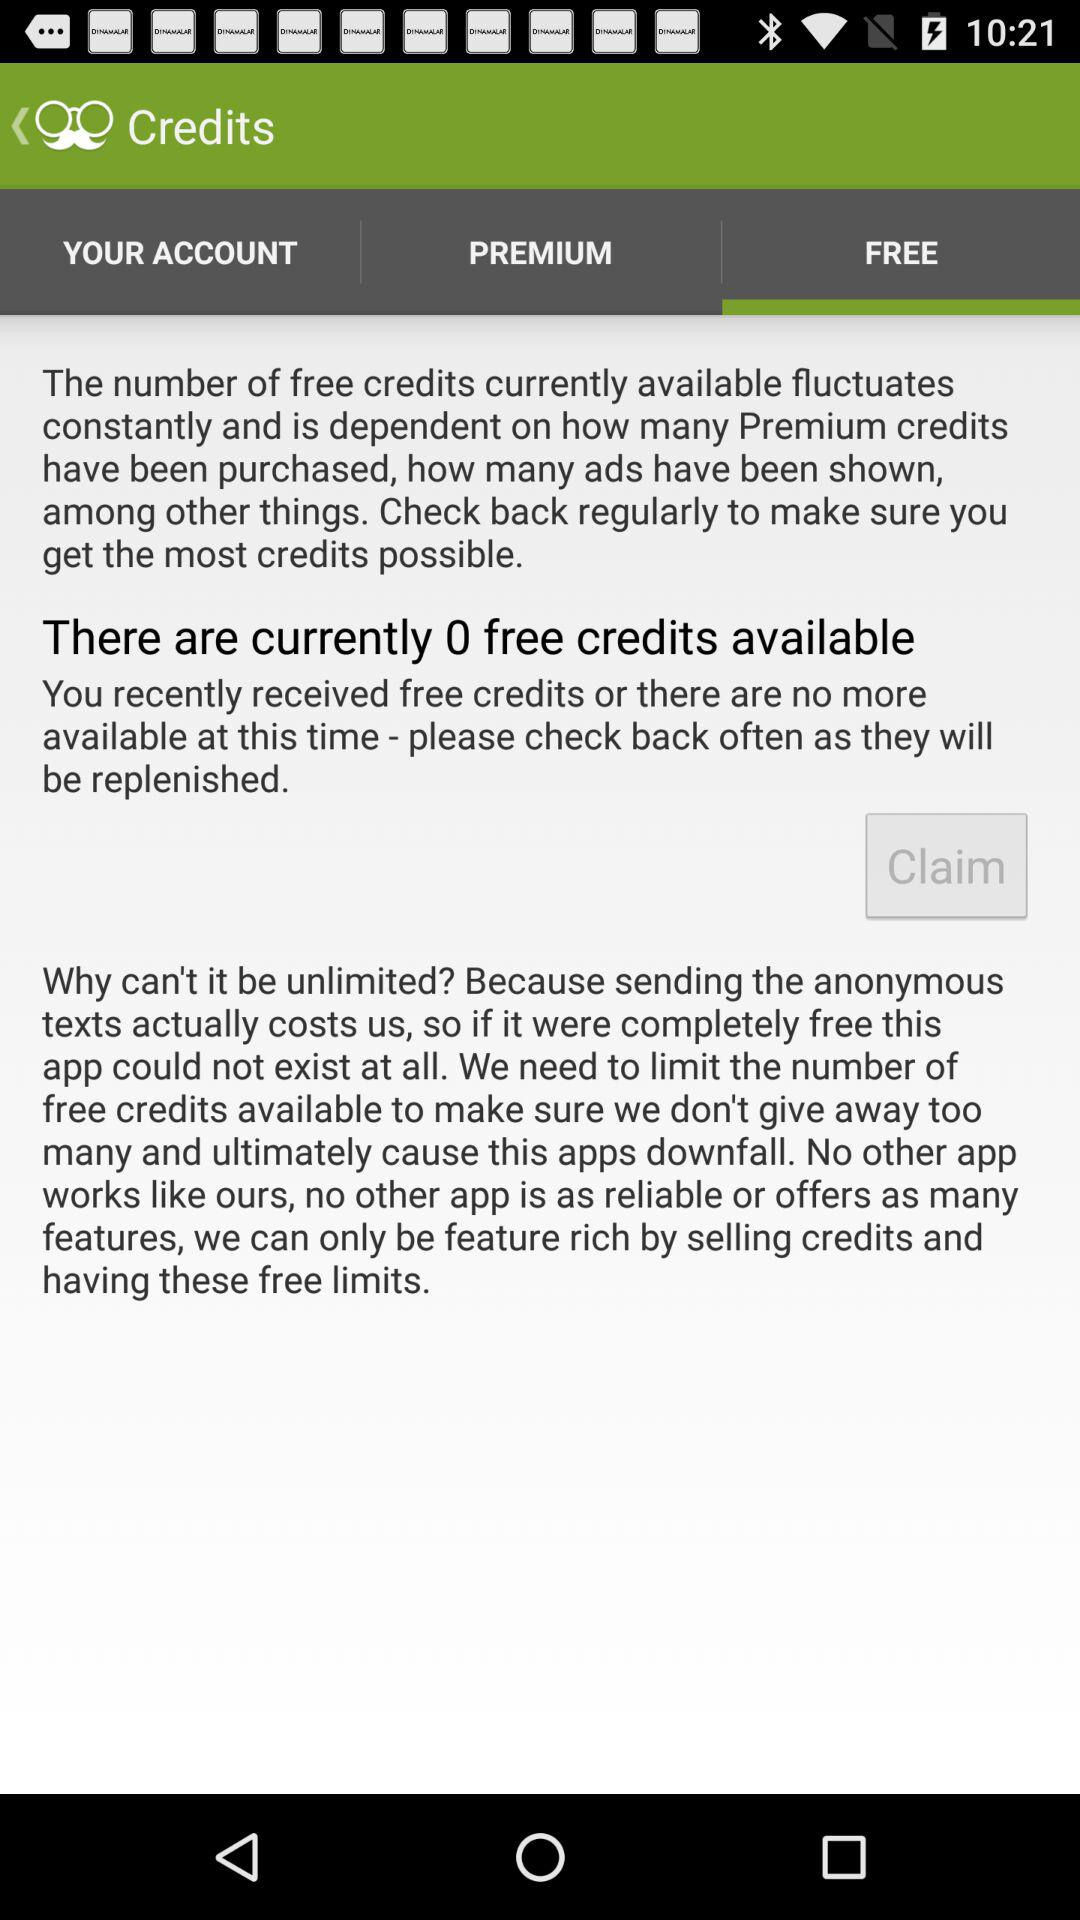What is the name of your account?
When the provided information is insufficient, respond with <no answer>. <no answer> 